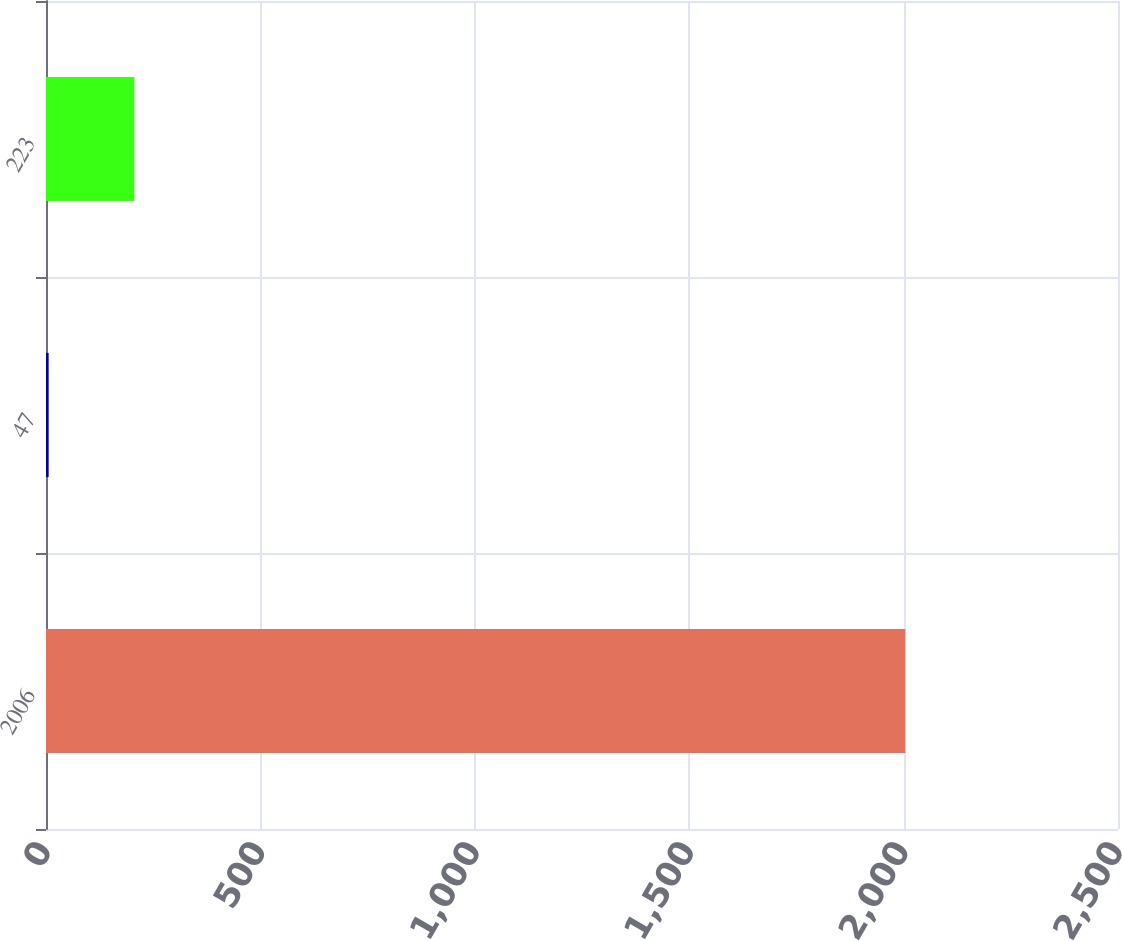<chart> <loc_0><loc_0><loc_500><loc_500><bar_chart><fcel>2006<fcel>47<fcel>223<nl><fcel>2004<fcel>6.2<fcel>205.98<nl></chart> 